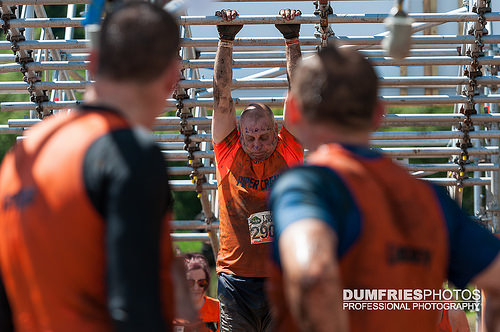<image>
Is there a woman behind the man? Yes. From this viewpoint, the woman is positioned behind the man, with the man partially or fully occluding the woman. 